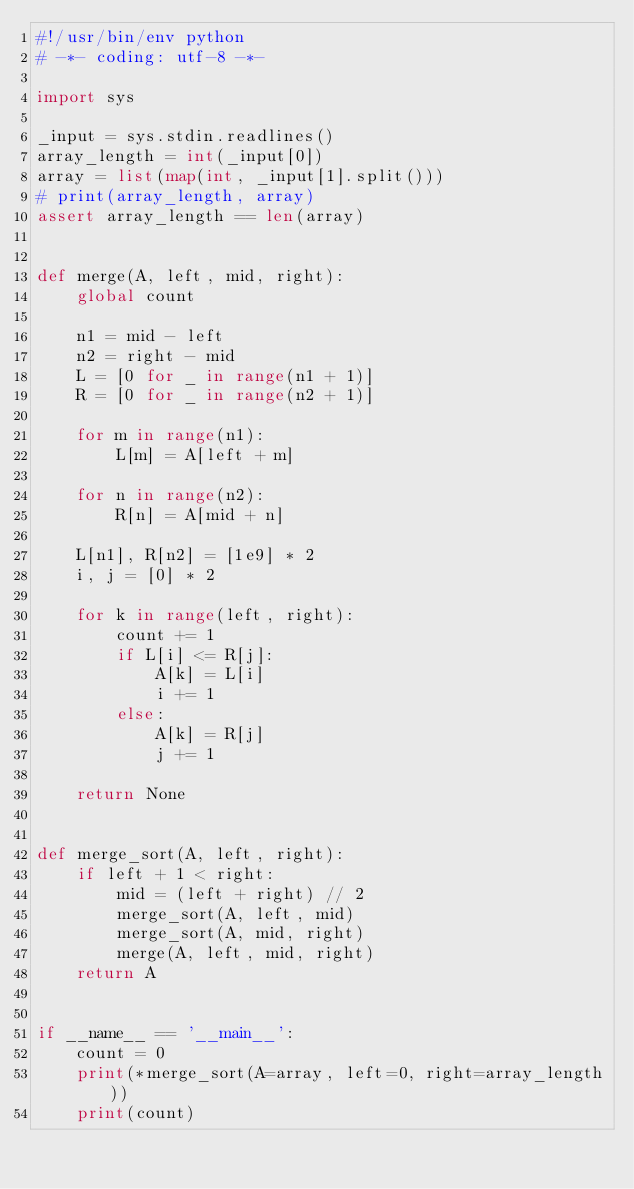Convert code to text. <code><loc_0><loc_0><loc_500><loc_500><_Python_>#!/usr/bin/env python
# -*- coding: utf-8 -*-

import sys

_input = sys.stdin.readlines()
array_length = int(_input[0])
array = list(map(int, _input[1].split()))
# print(array_length, array)
assert array_length == len(array)


def merge(A, left, mid, right):
    global count

    n1 = mid - left
    n2 = right - mid
    L = [0 for _ in range(n1 + 1)]
    R = [0 for _ in range(n2 + 1)]

    for m in range(n1):
        L[m] = A[left + m]

    for n in range(n2):
        R[n] = A[mid + n]

    L[n1], R[n2] = [1e9] * 2
    i, j = [0] * 2

    for k in range(left, right):
        count += 1
        if L[i] <= R[j]:
            A[k] = L[i]
            i += 1
        else:
            A[k] = R[j]
            j += 1

    return None


def merge_sort(A, left, right):
    if left + 1 < right:
        mid = (left + right) // 2
        merge_sort(A, left, mid)
        merge_sort(A, mid, right)
        merge(A, left, mid, right)
    return A


if __name__ == '__main__':
    count = 0
    print(*merge_sort(A=array, left=0, right=array_length))
    print(count)</code> 